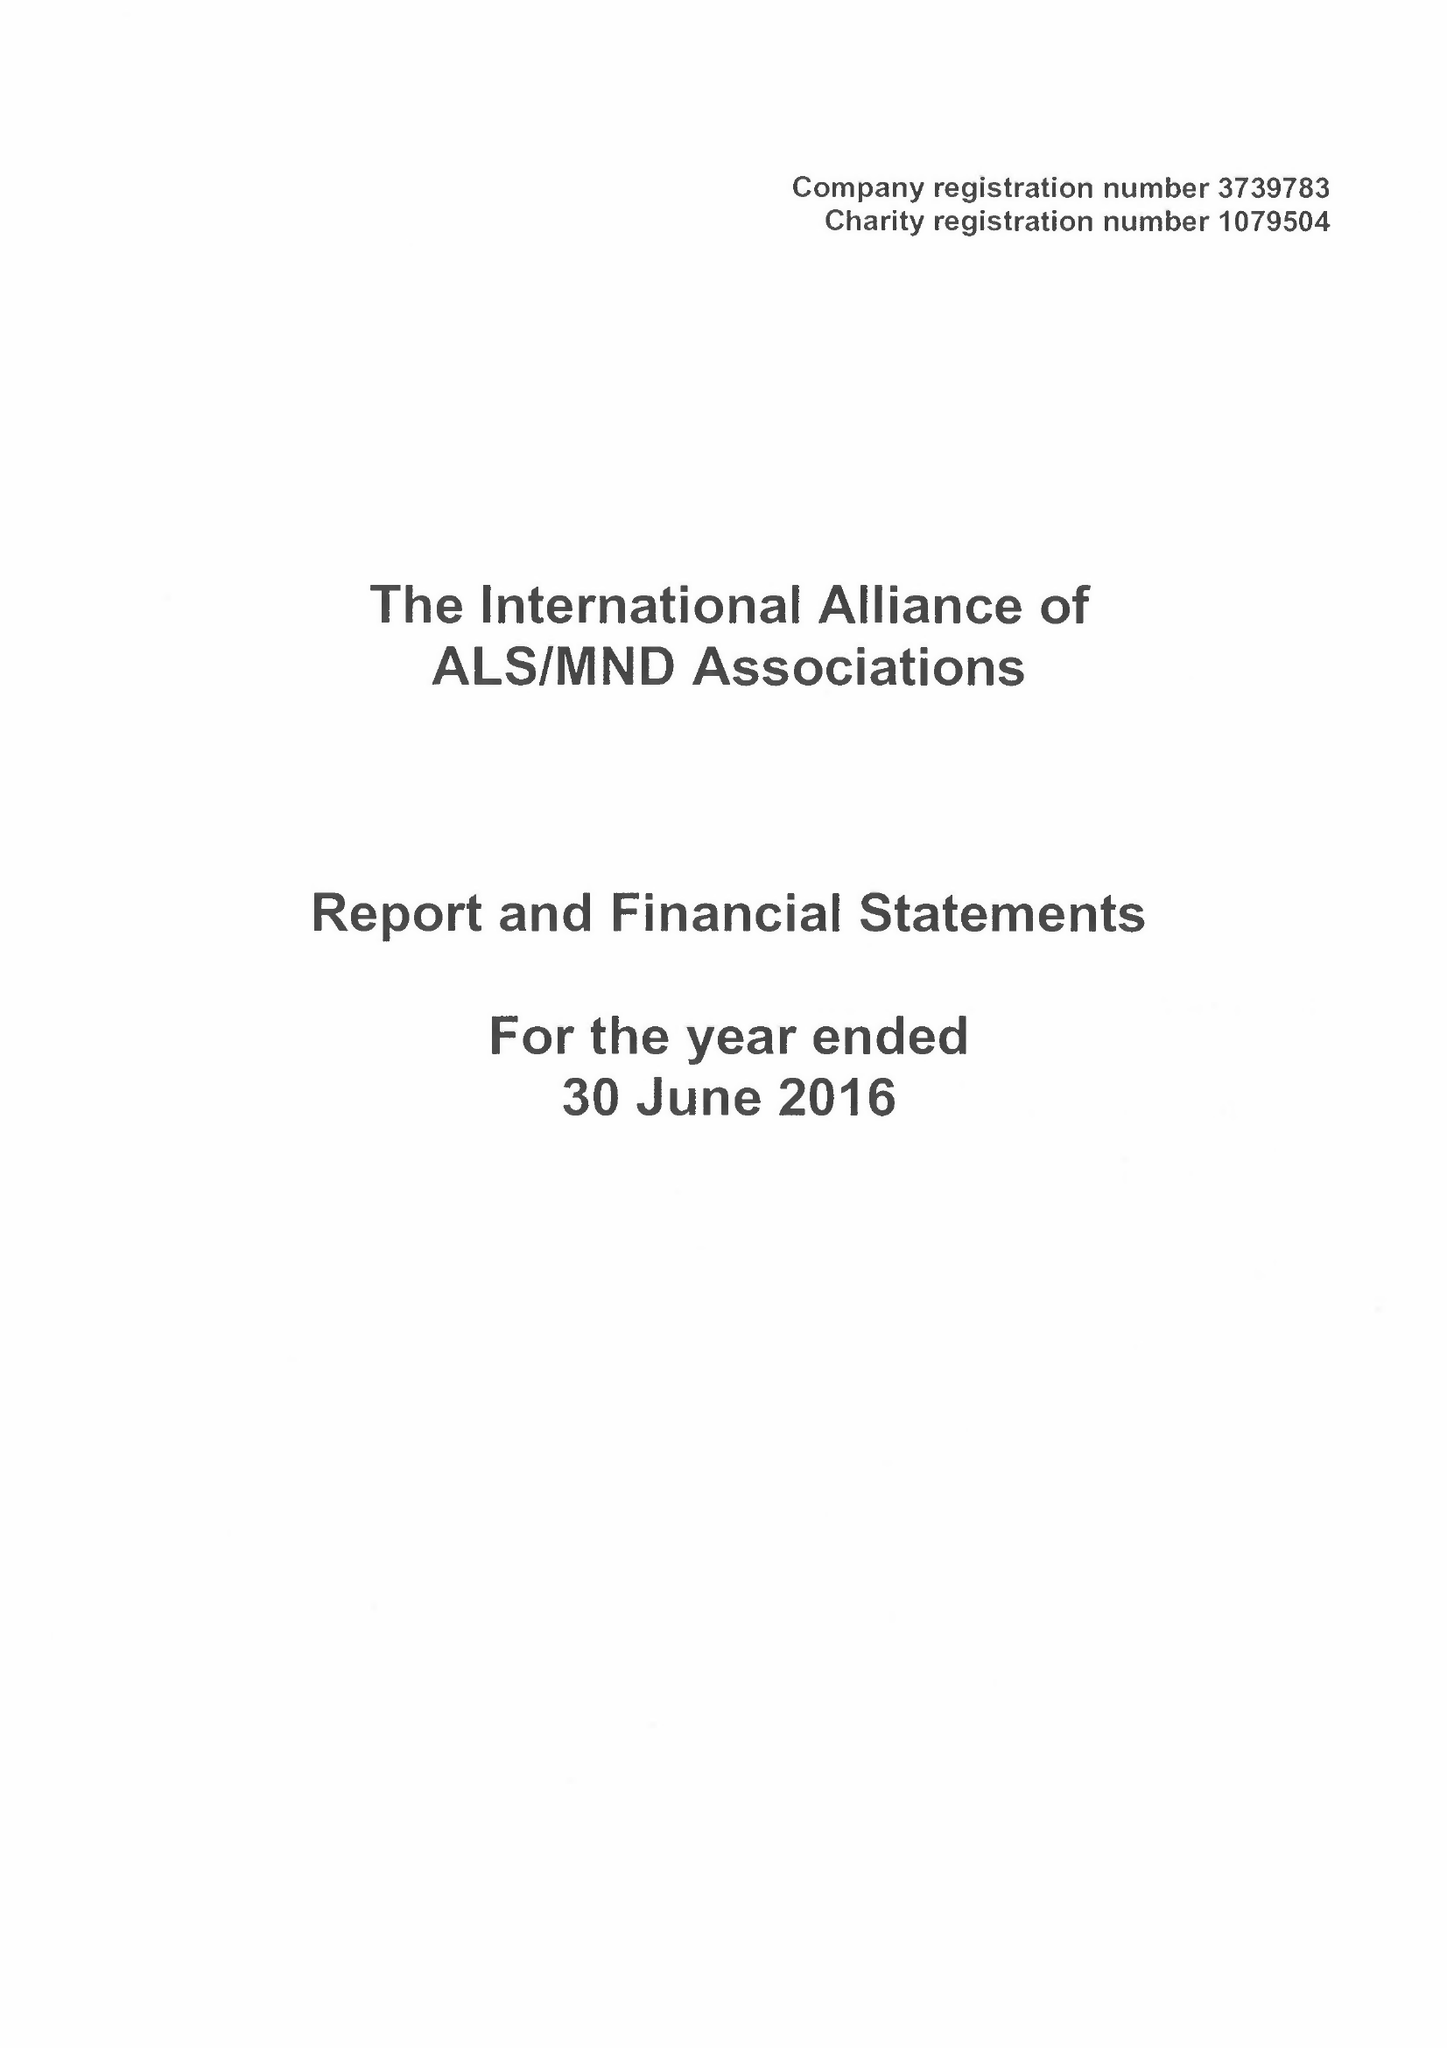What is the value for the address__street_line?
Answer the question using a single word or phrase. None 